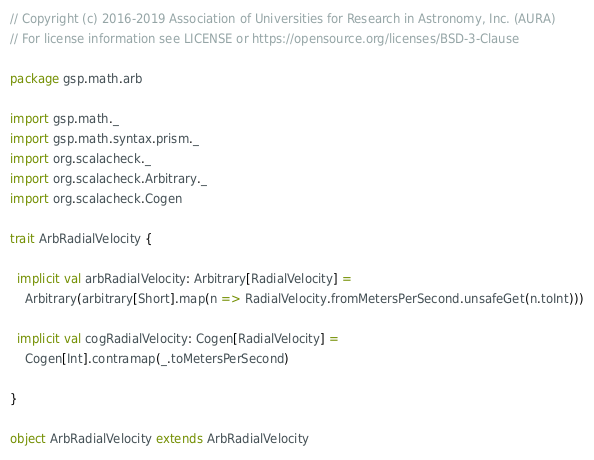<code> <loc_0><loc_0><loc_500><loc_500><_Scala_>// Copyright (c) 2016-2019 Association of Universities for Research in Astronomy, Inc. (AURA)
// For license information see LICENSE or https://opensource.org/licenses/BSD-3-Clause

package gsp.math.arb

import gsp.math._
import gsp.math.syntax.prism._
import org.scalacheck._
import org.scalacheck.Arbitrary._
import org.scalacheck.Cogen

trait ArbRadialVelocity {

  implicit val arbRadialVelocity: Arbitrary[RadialVelocity] =
    Arbitrary(arbitrary[Short].map(n => RadialVelocity.fromMetersPerSecond.unsafeGet(n.toInt)))

  implicit val cogRadialVelocity: Cogen[RadialVelocity] =
    Cogen[Int].contramap(_.toMetersPerSecond)

}

object ArbRadialVelocity extends ArbRadialVelocity
</code> 